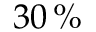<formula> <loc_0><loc_0><loc_500><loc_500>3 0 \, \%</formula> 